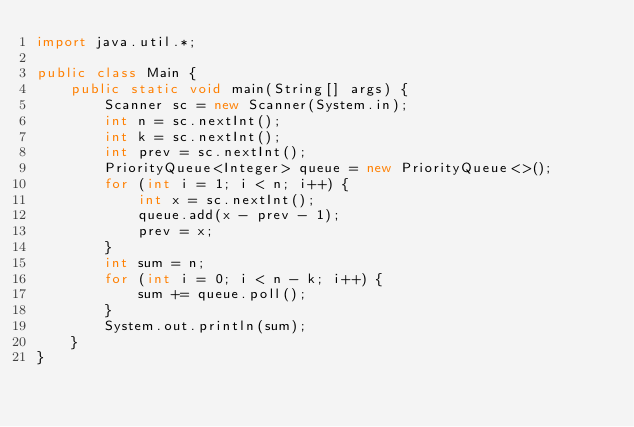Convert code to text. <code><loc_0><loc_0><loc_500><loc_500><_Java_>import java.util.*;

public class Main {
    public static void main(String[] args) {
        Scanner sc = new Scanner(System.in);
        int n = sc.nextInt();
        int k = sc.nextInt();
        int prev = sc.nextInt();
        PriorityQueue<Integer> queue = new PriorityQueue<>();
        for (int i = 1; i < n; i++) {
            int x = sc.nextInt();
            queue.add(x - prev - 1);
            prev = x;
        }
        int sum = n;
        for (int i = 0; i < n - k; i++) {
            sum += queue.poll();
        }
        System.out.println(sum);
    }
}
</code> 